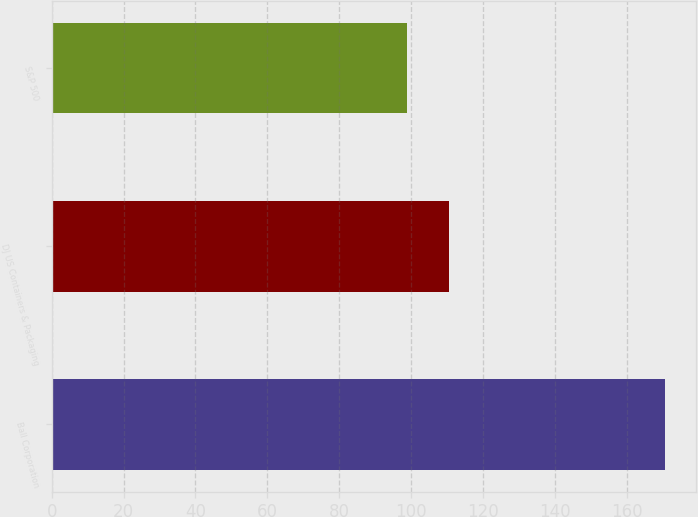Convert chart to OTSL. <chart><loc_0><loc_0><loc_500><loc_500><bar_chart><fcel>Ball Corporation<fcel>DJ US Containers & Packaging<fcel>S&P 500<nl><fcel>170.7<fcel>110.39<fcel>98.75<nl></chart> 